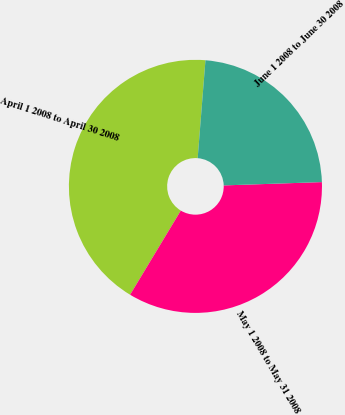Convert chart. <chart><loc_0><loc_0><loc_500><loc_500><pie_chart><fcel>April 1 2008 to April 30 2008<fcel>May 1 2008 to May 31 2008<fcel>June 1 2008 to June 30 2008<nl><fcel>42.63%<fcel>34.17%<fcel>23.2%<nl></chart> 